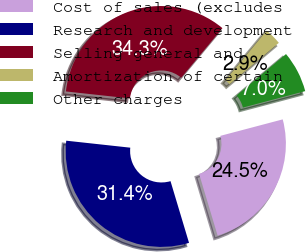Convert chart to OTSL. <chart><loc_0><loc_0><loc_500><loc_500><pie_chart><fcel>Cost of sales (excludes<fcel>Research and development<fcel>Selling general and<fcel>Amortization of certain<fcel>Other charges<nl><fcel>24.47%<fcel>31.37%<fcel>34.31%<fcel>2.86%<fcel>6.99%<nl></chart> 